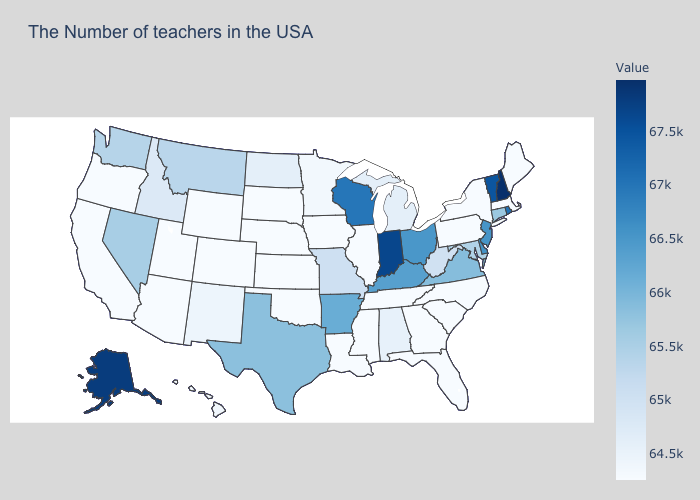Is the legend a continuous bar?
Give a very brief answer. Yes. Which states have the lowest value in the MidWest?
Give a very brief answer. Illinois, Iowa, Kansas, Nebraska, South Dakota. Does Tennessee have the lowest value in the USA?
Give a very brief answer. Yes. Is the legend a continuous bar?
Be succinct. Yes. 